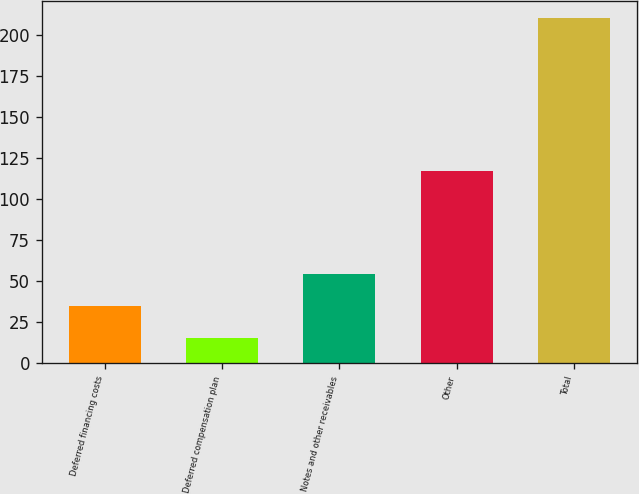Convert chart. <chart><loc_0><loc_0><loc_500><loc_500><bar_chart><fcel>Deferred financing costs<fcel>Deferred compensation plan<fcel>Notes and other receivables<fcel>Other<fcel>Total<nl><fcel>34.69<fcel>15.2<fcel>54.18<fcel>117.4<fcel>210.1<nl></chart> 